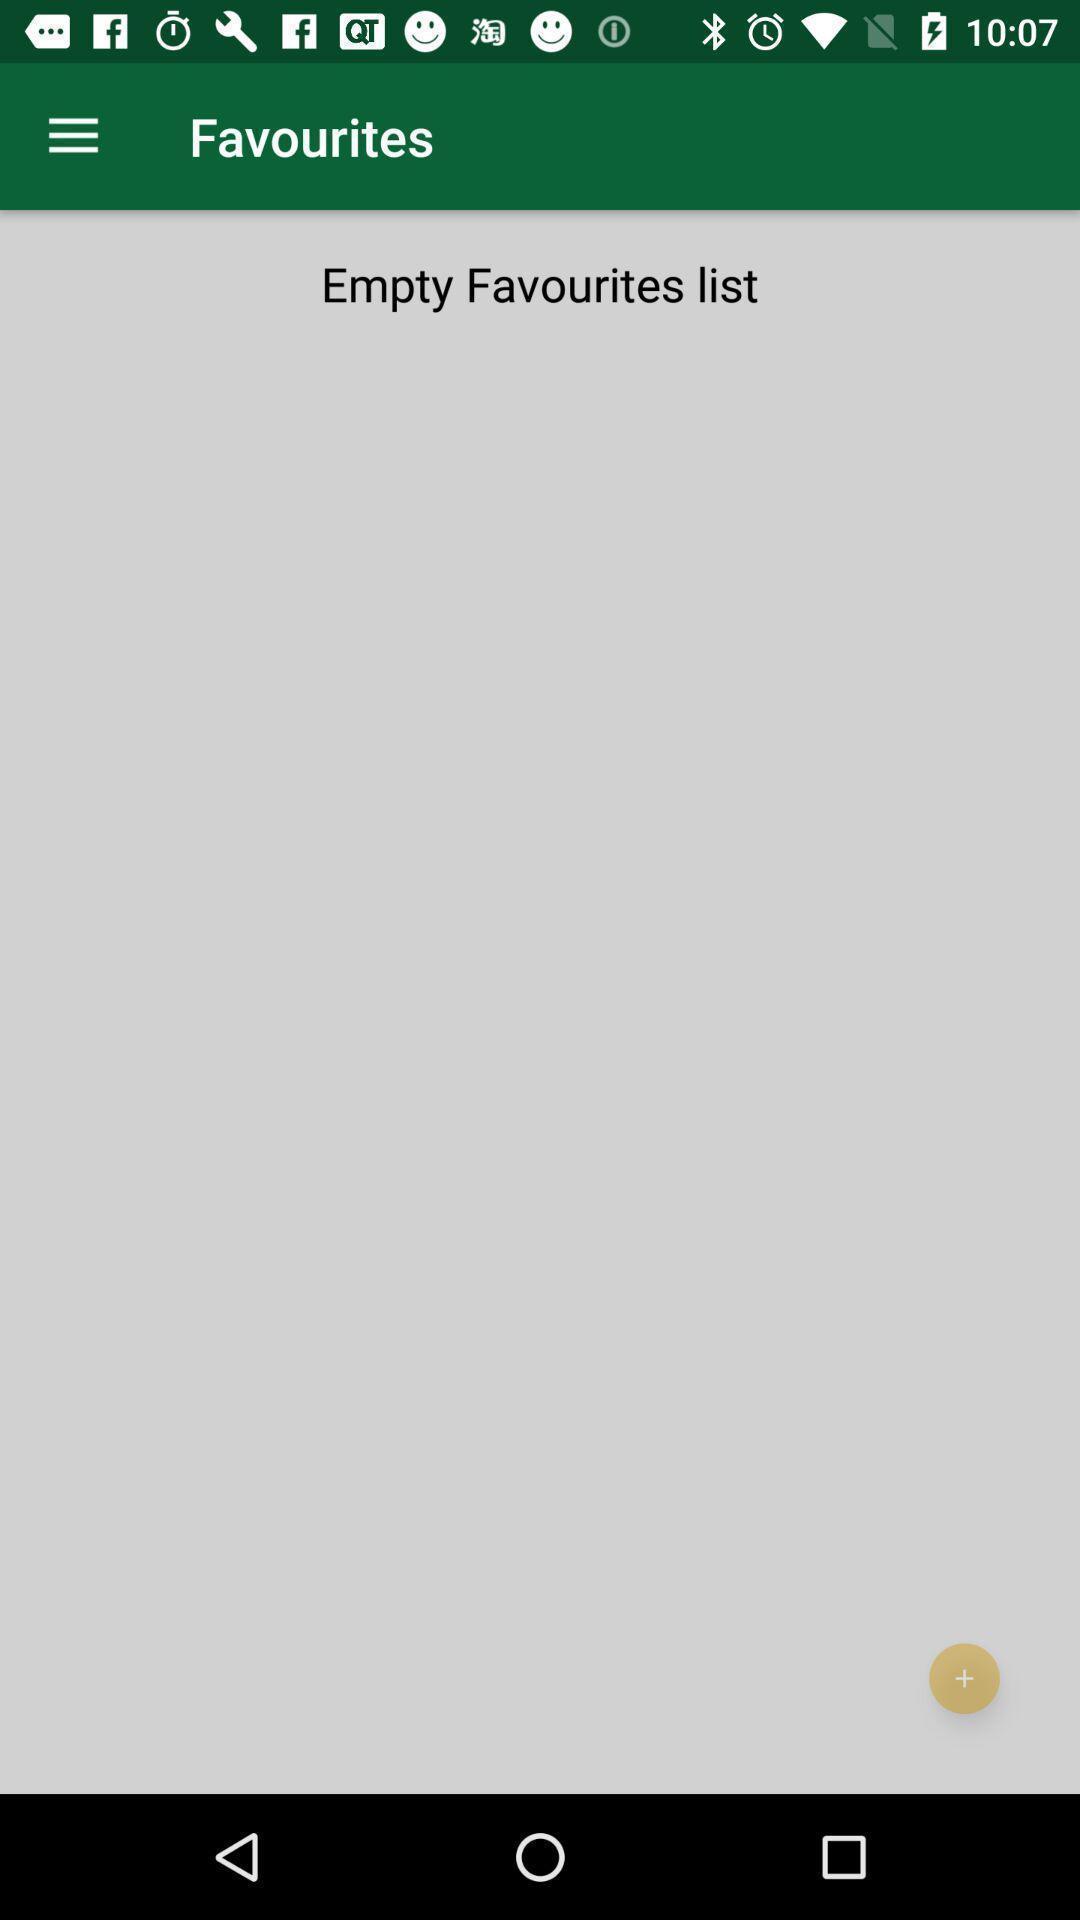What can you discern from this picture? Screen shows favourites. 